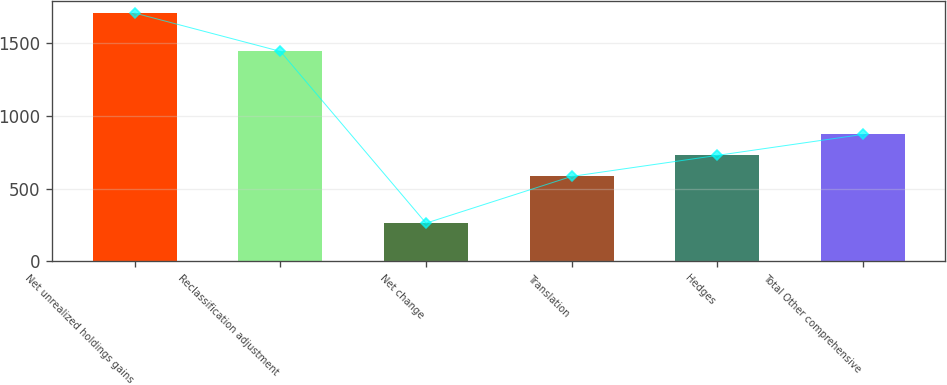Convert chart. <chart><loc_0><loc_0><loc_500><loc_500><bar_chart><fcel>Net unrealized holdings gains<fcel>Reclassification adjustment<fcel>Net change<fcel>Translation<fcel>Hedges<fcel>Total Other comprehensive<nl><fcel>1706<fcel>1443<fcel>263<fcel>584<fcel>728.3<fcel>872.6<nl></chart> 